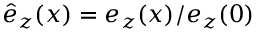<formula> <loc_0><loc_0><loc_500><loc_500>{ \hat { e } _ { z } ( x ) = e _ { z } ( x ) / e _ { z } ( 0 ) }</formula> 